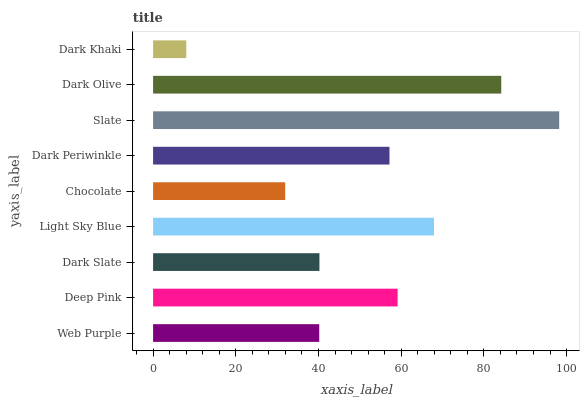Is Dark Khaki the minimum?
Answer yes or no. Yes. Is Slate the maximum?
Answer yes or no. Yes. Is Deep Pink the minimum?
Answer yes or no. No. Is Deep Pink the maximum?
Answer yes or no. No. Is Deep Pink greater than Web Purple?
Answer yes or no. Yes. Is Web Purple less than Deep Pink?
Answer yes or no. Yes. Is Web Purple greater than Deep Pink?
Answer yes or no. No. Is Deep Pink less than Web Purple?
Answer yes or no. No. Is Dark Periwinkle the high median?
Answer yes or no. Yes. Is Dark Periwinkle the low median?
Answer yes or no. Yes. Is Dark Khaki the high median?
Answer yes or no. No. Is Chocolate the low median?
Answer yes or no. No. 